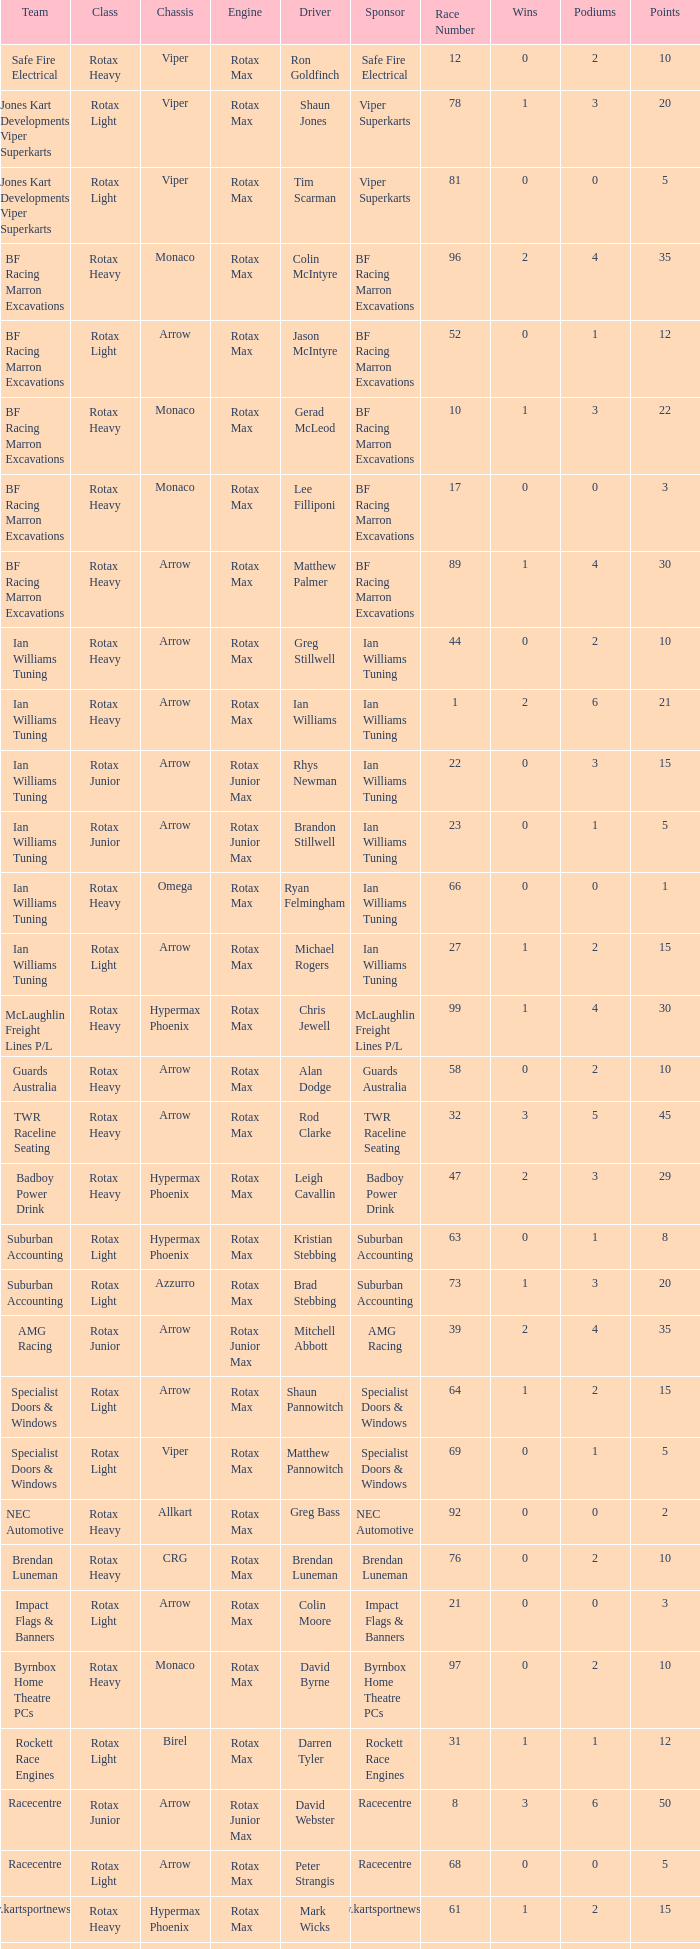What is the name of the team whose class is Rotax Light? Jones Kart Developments Viper Superkarts, Jones Kart Developments Viper Superkarts, BF Racing Marron Excavations, Ian Williams Tuning, Suburban Accounting, Suburban Accounting, Specialist Doors & Windows, Specialist Doors & Windows, Impact Flags & Banners, Rockett Race Engines, Racecentre, Doug Savage. 